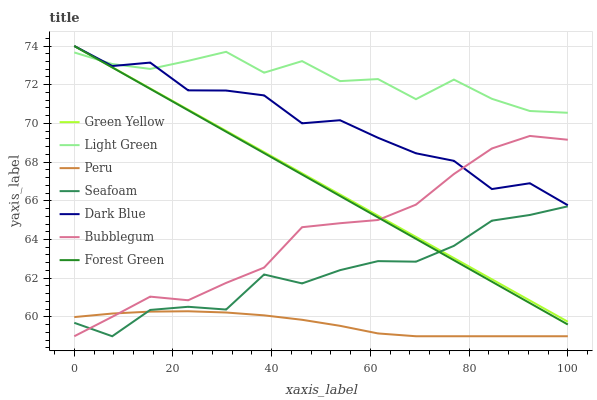Does Peru have the minimum area under the curve?
Answer yes or no. Yes. Does Light Green have the maximum area under the curve?
Answer yes or no. Yes. Does Seafoam have the minimum area under the curve?
Answer yes or no. No. Does Seafoam have the maximum area under the curve?
Answer yes or no. No. Is Green Yellow the smoothest?
Answer yes or no. Yes. Is Light Green the roughest?
Answer yes or no. Yes. Is Seafoam the smoothest?
Answer yes or no. No. Is Seafoam the roughest?
Answer yes or no. No. Does Seafoam have the lowest value?
Answer yes or no. Yes. Does Dark Blue have the lowest value?
Answer yes or no. No. Does Green Yellow have the highest value?
Answer yes or no. Yes. Does Seafoam have the highest value?
Answer yes or no. No. Is Seafoam less than Light Green?
Answer yes or no. Yes. Is Dark Blue greater than Seafoam?
Answer yes or no. Yes. Does Peru intersect Bubblegum?
Answer yes or no. Yes. Is Peru less than Bubblegum?
Answer yes or no. No. Is Peru greater than Bubblegum?
Answer yes or no. No. Does Seafoam intersect Light Green?
Answer yes or no. No. 